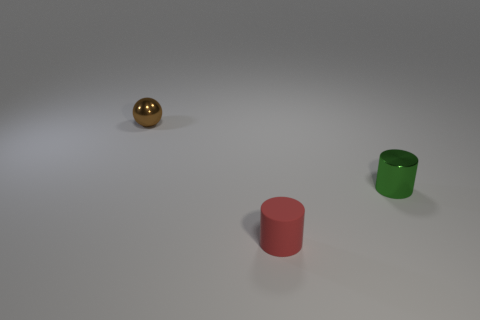The tiny object in front of the metal cylinder has what shape?
Your answer should be compact. Cylinder. The object that is behind the thing on the right side of the small red cylinder is what shape?
Provide a succinct answer. Sphere. Are there any other tiny green objects that have the same shape as the small matte object?
Your answer should be very brief. Yes. There is a green metal thing that is the same size as the red rubber object; what is its shape?
Ensure brevity in your answer.  Cylinder. Are there any red objects to the left of the object that is in front of the tiny metallic object to the right of the shiny ball?
Make the answer very short. No. Is there another red rubber object that has the same size as the red rubber object?
Your response must be concise. No. What color is the small shiny object to the right of the small metallic thing that is behind the cylinder that is on the right side of the small red cylinder?
Your answer should be very brief. Green. There is a cylinder that is left of the tiny metallic object on the right side of the red matte cylinder; what is its color?
Ensure brevity in your answer.  Red. Are there more red things that are to the left of the green thing than tiny metal balls behind the small brown shiny ball?
Ensure brevity in your answer.  Yes. Is the material of the small object behind the small metal cylinder the same as the cylinder that is on the right side of the red matte object?
Make the answer very short. Yes. 